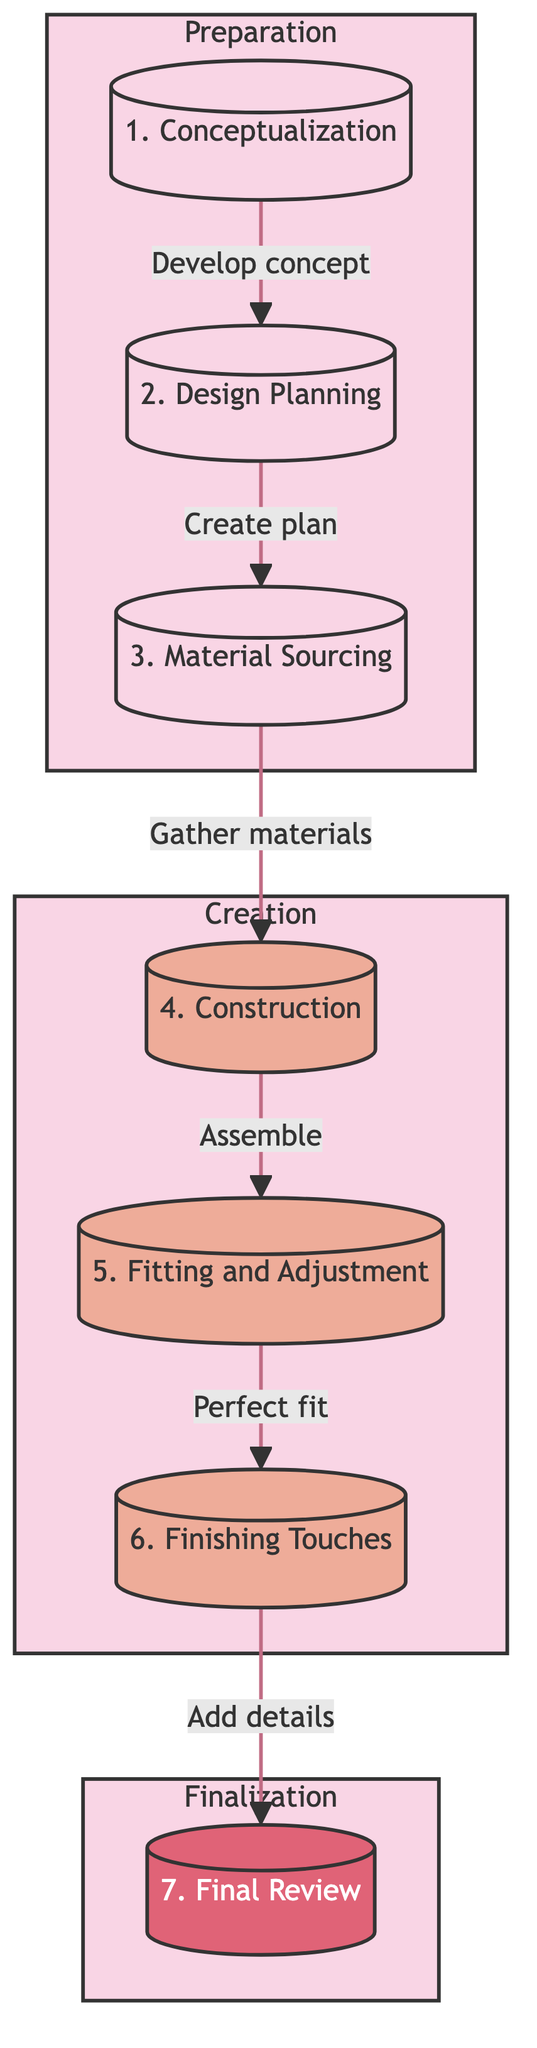What is the first step in the costume creation workflow? The diagram indicates that the first step is "Conceptualization". This is shown as the starting point at the top of the flowchart.
Answer: Conceptualization How many major phases are there in the workflow? The diagram has three distinct phases: Preparation, Creation, and Finalization. Each phase groups specific steps, which can be counted from the subgraph sections.
Answer: Three What process comes after "Material Sourcing"? Based on the flow direction in the diagram, the process that follows "Material Sourcing" is "Construction". This is indicated by the arrow leading to the next node.
Answer: Construction What is the last step before the final review? The diagram shows that "Finishing Touches" is the process that comes before "Final Review". This is determined by tracing the flow from the previous steps to the end.
Answer: Finishing Touches What tools are represented in the "Finishing Touches" step? The tools mentioned in the "Finishing Touches" section include fabric paint, embroidery tools, and airbrush, which are listed under the details of that step in the diagram.
Answer: Fabric paint, embroidery tools, airbrush Which step involves creating detailed sketches from different angles? The diagram specifies that the step "Design Planning" includes the substep of creating detailed sketches from various angles. This connection is direct from the description of that phase.
Answer: Design Planning What is the primary action in the "Fitting and Adjustment" step? The main action described in "Fitting and Adjustment" is to ensure the costume fits perfectly, which encompasses various related substeps listed in the details of that phase.
Answer: Ensure the costume fits perfectly Which tools are primarily used in the "Construction" phase? According to the diagram, the tools needed for the "Construction" step include sewing machine, needles and thread, glue gun, and crafting tools. These are directly listed under that particular step.
Answer: Sewing machine, needles and thread, glue gun, crafting tools 